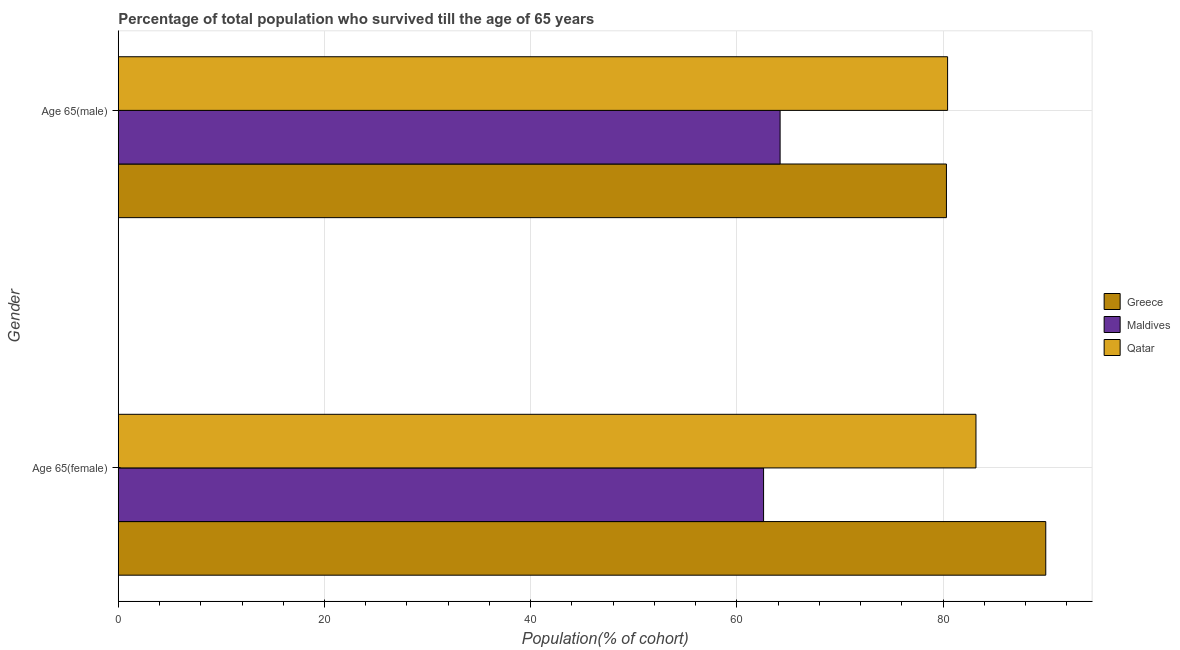How many different coloured bars are there?
Offer a terse response. 3. How many groups of bars are there?
Keep it short and to the point. 2. Are the number of bars per tick equal to the number of legend labels?
Provide a short and direct response. Yes. Are the number of bars on each tick of the Y-axis equal?
Ensure brevity in your answer.  Yes. How many bars are there on the 1st tick from the top?
Your response must be concise. 3. What is the label of the 2nd group of bars from the top?
Your answer should be very brief. Age 65(female). What is the percentage of male population who survived till age of 65 in Qatar?
Offer a terse response. 80.44. Across all countries, what is the maximum percentage of male population who survived till age of 65?
Make the answer very short. 80.44. Across all countries, what is the minimum percentage of male population who survived till age of 65?
Your answer should be very brief. 64.2. In which country was the percentage of male population who survived till age of 65 minimum?
Provide a short and direct response. Maldives. What is the total percentage of female population who survived till age of 65 in the graph?
Give a very brief answer. 235.76. What is the difference between the percentage of male population who survived till age of 65 in Maldives and that in Greece?
Your answer should be compact. -16.13. What is the difference between the percentage of male population who survived till age of 65 in Qatar and the percentage of female population who survived till age of 65 in Greece?
Your response must be concise. -9.52. What is the average percentage of male population who survived till age of 65 per country?
Keep it short and to the point. 74.99. What is the difference between the percentage of male population who survived till age of 65 and percentage of female population who survived till age of 65 in Greece?
Your answer should be very brief. -9.63. In how many countries, is the percentage of female population who survived till age of 65 greater than 8 %?
Offer a terse response. 3. What is the ratio of the percentage of female population who survived till age of 65 in Greece to that in Maldives?
Keep it short and to the point. 1.44. In how many countries, is the percentage of female population who survived till age of 65 greater than the average percentage of female population who survived till age of 65 taken over all countries?
Your answer should be compact. 2. What does the 1st bar from the top in Age 65(female) represents?
Ensure brevity in your answer.  Qatar. What does the 3rd bar from the bottom in Age 65(male) represents?
Ensure brevity in your answer.  Qatar. How many bars are there?
Keep it short and to the point. 6. What is the difference between two consecutive major ticks on the X-axis?
Ensure brevity in your answer.  20. Are the values on the major ticks of X-axis written in scientific E-notation?
Provide a succinct answer. No. Does the graph contain any zero values?
Your response must be concise. No. Does the graph contain grids?
Keep it short and to the point. Yes. Where does the legend appear in the graph?
Your response must be concise. Center right. How many legend labels are there?
Your response must be concise. 3. How are the legend labels stacked?
Keep it short and to the point. Vertical. What is the title of the graph?
Keep it short and to the point. Percentage of total population who survived till the age of 65 years. Does "Guyana" appear as one of the legend labels in the graph?
Give a very brief answer. No. What is the label or title of the X-axis?
Give a very brief answer. Population(% of cohort). What is the Population(% of cohort) of Greece in Age 65(female)?
Provide a succinct answer. 89.97. What is the Population(% of cohort) of Maldives in Age 65(female)?
Provide a short and direct response. 62.59. What is the Population(% of cohort) of Qatar in Age 65(female)?
Make the answer very short. 83.2. What is the Population(% of cohort) in Greece in Age 65(male)?
Your response must be concise. 80.33. What is the Population(% of cohort) of Maldives in Age 65(male)?
Ensure brevity in your answer.  64.2. What is the Population(% of cohort) in Qatar in Age 65(male)?
Offer a very short reply. 80.44. Across all Gender, what is the maximum Population(% of cohort) in Greece?
Offer a very short reply. 89.97. Across all Gender, what is the maximum Population(% of cohort) in Maldives?
Keep it short and to the point. 64.2. Across all Gender, what is the maximum Population(% of cohort) of Qatar?
Keep it short and to the point. 83.2. Across all Gender, what is the minimum Population(% of cohort) of Greece?
Provide a succinct answer. 80.33. Across all Gender, what is the minimum Population(% of cohort) of Maldives?
Ensure brevity in your answer.  62.59. Across all Gender, what is the minimum Population(% of cohort) in Qatar?
Keep it short and to the point. 80.44. What is the total Population(% of cohort) in Greece in the graph?
Make the answer very short. 170.3. What is the total Population(% of cohort) of Maldives in the graph?
Keep it short and to the point. 126.79. What is the total Population(% of cohort) of Qatar in the graph?
Give a very brief answer. 163.64. What is the difference between the Population(% of cohort) of Greece in Age 65(female) and that in Age 65(male)?
Keep it short and to the point. 9.63. What is the difference between the Population(% of cohort) in Maldives in Age 65(female) and that in Age 65(male)?
Make the answer very short. -1.6. What is the difference between the Population(% of cohort) in Qatar in Age 65(female) and that in Age 65(male)?
Provide a short and direct response. 2.75. What is the difference between the Population(% of cohort) of Greece in Age 65(female) and the Population(% of cohort) of Maldives in Age 65(male)?
Offer a very short reply. 25.77. What is the difference between the Population(% of cohort) of Greece in Age 65(female) and the Population(% of cohort) of Qatar in Age 65(male)?
Ensure brevity in your answer.  9.52. What is the difference between the Population(% of cohort) of Maldives in Age 65(female) and the Population(% of cohort) of Qatar in Age 65(male)?
Offer a terse response. -17.85. What is the average Population(% of cohort) of Greece per Gender?
Ensure brevity in your answer.  85.15. What is the average Population(% of cohort) of Maldives per Gender?
Provide a succinct answer. 63.4. What is the average Population(% of cohort) in Qatar per Gender?
Provide a succinct answer. 81.82. What is the difference between the Population(% of cohort) of Greece and Population(% of cohort) of Maldives in Age 65(female)?
Your response must be concise. 27.37. What is the difference between the Population(% of cohort) in Greece and Population(% of cohort) in Qatar in Age 65(female)?
Ensure brevity in your answer.  6.77. What is the difference between the Population(% of cohort) in Maldives and Population(% of cohort) in Qatar in Age 65(female)?
Provide a short and direct response. -20.6. What is the difference between the Population(% of cohort) of Greece and Population(% of cohort) of Maldives in Age 65(male)?
Your response must be concise. 16.13. What is the difference between the Population(% of cohort) of Greece and Population(% of cohort) of Qatar in Age 65(male)?
Keep it short and to the point. -0.11. What is the difference between the Population(% of cohort) of Maldives and Population(% of cohort) of Qatar in Age 65(male)?
Your response must be concise. -16.25. What is the ratio of the Population(% of cohort) of Greece in Age 65(female) to that in Age 65(male)?
Give a very brief answer. 1.12. What is the ratio of the Population(% of cohort) in Qatar in Age 65(female) to that in Age 65(male)?
Keep it short and to the point. 1.03. What is the difference between the highest and the second highest Population(% of cohort) in Greece?
Keep it short and to the point. 9.63. What is the difference between the highest and the second highest Population(% of cohort) of Maldives?
Your answer should be compact. 1.6. What is the difference between the highest and the second highest Population(% of cohort) in Qatar?
Make the answer very short. 2.75. What is the difference between the highest and the lowest Population(% of cohort) of Greece?
Make the answer very short. 9.63. What is the difference between the highest and the lowest Population(% of cohort) of Maldives?
Keep it short and to the point. 1.6. What is the difference between the highest and the lowest Population(% of cohort) in Qatar?
Offer a very short reply. 2.75. 